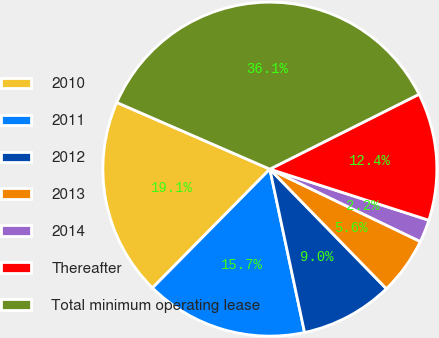Convert chart. <chart><loc_0><loc_0><loc_500><loc_500><pie_chart><fcel>2010<fcel>2011<fcel>2012<fcel>2013<fcel>2014<fcel>Thereafter<fcel>Total minimum operating lease<nl><fcel>19.13%<fcel>15.74%<fcel>8.96%<fcel>5.57%<fcel>2.19%<fcel>12.35%<fcel>36.06%<nl></chart> 